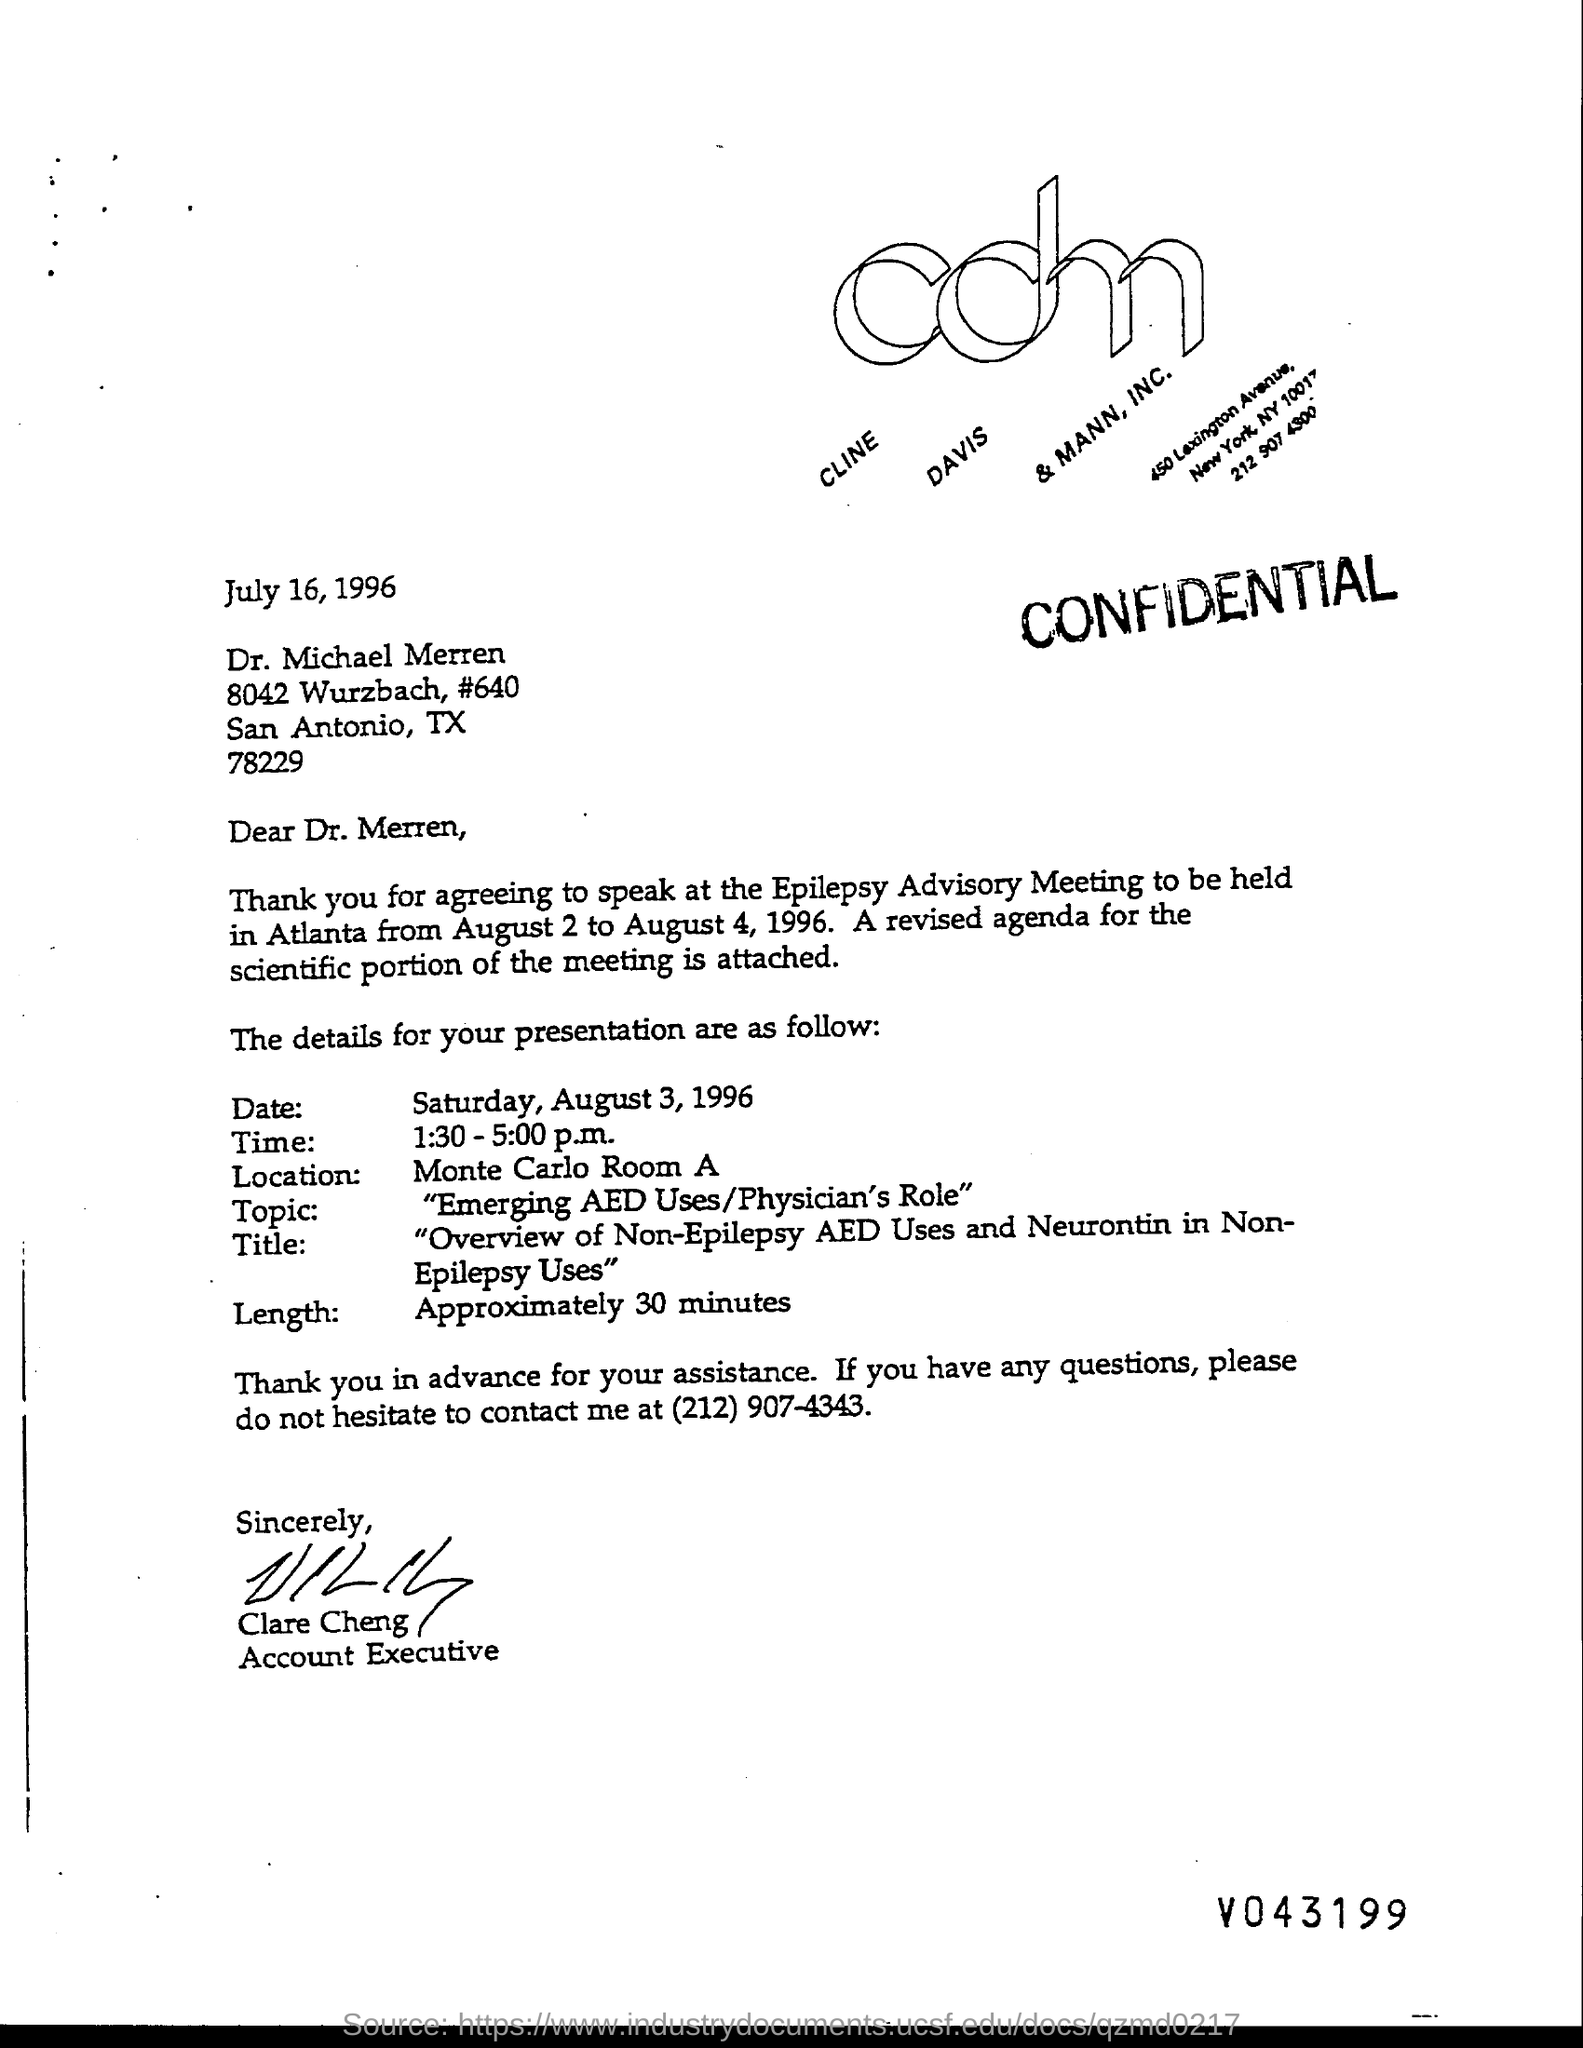Who is the account executive?
Offer a terse response. Clare Cheng. What is the name of the location?
Offer a terse response. Monte Carlo Room A. What is the length?
Keep it short and to the point. Approximately 30 minutes. 